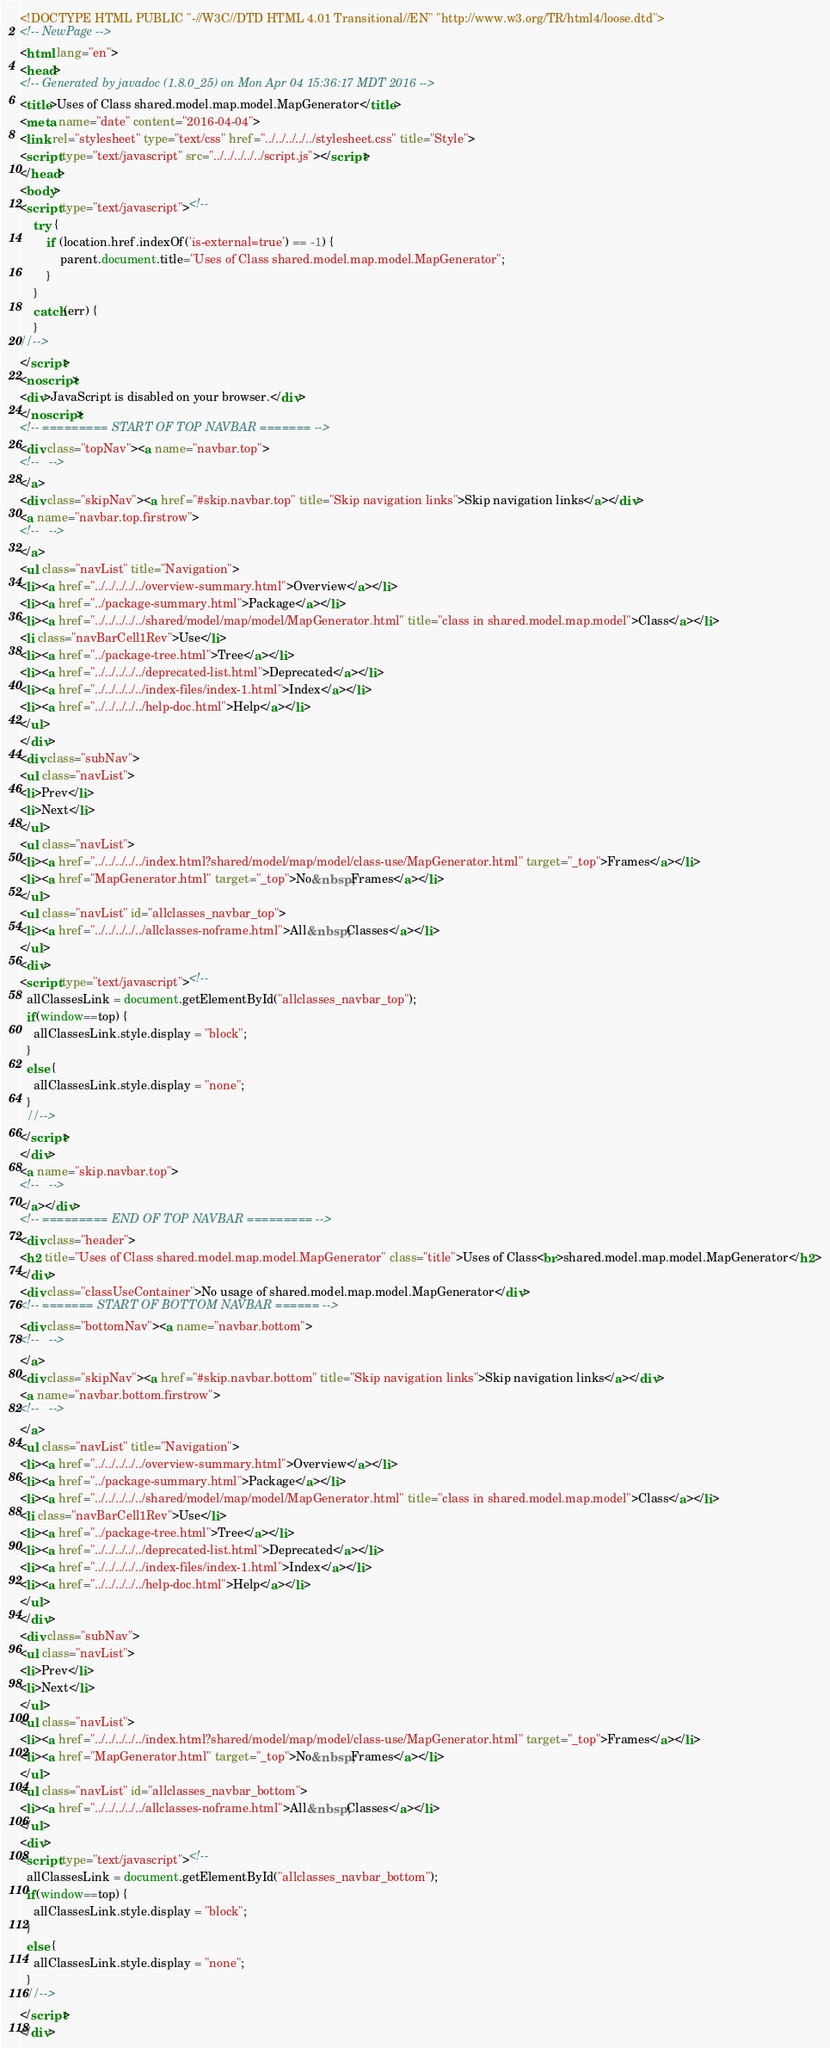Convert code to text. <code><loc_0><loc_0><loc_500><loc_500><_HTML_><!DOCTYPE HTML PUBLIC "-//W3C//DTD HTML 4.01 Transitional//EN" "http://www.w3.org/TR/html4/loose.dtd">
<!-- NewPage -->
<html lang="en">
<head>
<!-- Generated by javadoc (1.8.0_25) on Mon Apr 04 15:36:17 MDT 2016 -->
<title>Uses of Class shared.model.map.model.MapGenerator</title>
<meta name="date" content="2016-04-04">
<link rel="stylesheet" type="text/css" href="../../../../../stylesheet.css" title="Style">
<script type="text/javascript" src="../../../../../script.js"></script>
</head>
<body>
<script type="text/javascript"><!--
    try {
        if (location.href.indexOf('is-external=true') == -1) {
            parent.document.title="Uses of Class shared.model.map.model.MapGenerator";
        }
    }
    catch(err) {
    }
//-->
</script>
<noscript>
<div>JavaScript is disabled on your browser.</div>
</noscript>
<!-- ========= START OF TOP NAVBAR ======= -->
<div class="topNav"><a name="navbar.top">
<!--   -->
</a>
<div class="skipNav"><a href="#skip.navbar.top" title="Skip navigation links">Skip navigation links</a></div>
<a name="navbar.top.firstrow">
<!--   -->
</a>
<ul class="navList" title="Navigation">
<li><a href="../../../../../overview-summary.html">Overview</a></li>
<li><a href="../package-summary.html">Package</a></li>
<li><a href="../../../../../shared/model/map/model/MapGenerator.html" title="class in shared.model.map.model">Class</a></li>
<li class="navBarCell1Rev">Use</li>
<li><a href="../package-tree.html">Tree</a></li>
<li><a href="../../../../../deprecated-list.html">Deprecated</a></li>
<li><a href="../../../../../index-files/index-1.html">Index</a></li>
<li><a href="../../../../../help-doc.html">Help</a></li>
</ul>
</div>
<div class="subNav">
<ul class="navList">
<li>Prev</li>
<li>Next</li>
</ul>
<ul class="navList">
<li><a href="../../../../../index.html?shared/model/map/model/class-use/MapGenerator.html" target="_top">Frames</a></li>
<li><a href="MapGenerator.html" target="_top">No&nbsp;Frames</a></li>
</ul>
<ul class="navList" id="allclasses_navbar_top">
<li><a href="../../../../../allclasses-noframe.html">All&nbsp;Classes</a></li>
</ul>
<div>
<script type="text/javascript"><!--
  allClassesLink = document.getElementById("allclasses_navbar_top");
  if(window==top) {
    allClassesLink.style.display = "block";
  }
  else {
    allClassesLink.style.display = "none";
  }
  //-->
</script>
</div>
<a name="skip.navbar.top">
<!--   -->
</a></div>
<!-- ========= END OF TOP NAVBAR ========= -->
<div class="header">
<h2 title="Uses of Class shared.model.map.model.MapGenerator" class="title">Uses of Class<br>shared.model.map.model.MapGenerator</h2>
</div>
<div class="classUseContainer">No usage of shared.model.map.model.MapGenerator</div>
<!-- ======= START OF BOTTOM NAVBAR ====== -->
<div class="bottomNav"><a name="navbar.bottom">
<!--   -->
</a>
<div class="skipNav"><a href="#skip.navbar.bottom" title="Skip navigation links">Skip navigation links</a></div>
<a name="navbar.bottom.firstrow">
<!--   -->
</a>
<ul class="navList" title="Navigation">
<li><a href="../../../../../overview-summary.html">Overview</a></li>
<li><a href="../package-summary.html">Package</a></li>
<li><a href="../../../../../shared/model/map/model/MapGenerator.html" title="class in shared.model.map.model">Class</a></li>
<li class="navBarCell1Rev">Use</li>
<li><a href="../package-tree.html">Tree</a></li>
<li><a href="../../../../../deprecated-list.html">Deprecated</a></li>
<li><a href="../../../../../index-files/index-1.html">Index</a></li>
<li><a href="../../../../../help-doc.html">Help</a></li>
</ul>
</div>
<div class="subNav">
<ul class="navList">
<li>Prev</li>
<li>Next</li>
</ul>
<ul class="navList">
<li><a href="../../../../../index.html?shared/model/map/model/class-use/MapGenerator.html" target="_top">Frames</a></li>
<li><a href="MapGenerator.html" target="_top">No&nbsp;Frames</a></li>
</ul>
<ul class="navList" id="allclasses_navbar_bottom">
<li><a href="../../../../../allclasses-noframe.html">All&nbsp;Classes</a></li>
</ul>
<div>
<script type="text/javascript"><!--
  allClassesLink = document.getElementById("allclasses_navbar_bottom");
  if(window==top) {
    allClassesLink.style.display = "block";
  }
  else {
    allClassesLink.style.display = "none";
  }
  //-->
</script>
</div></code> 